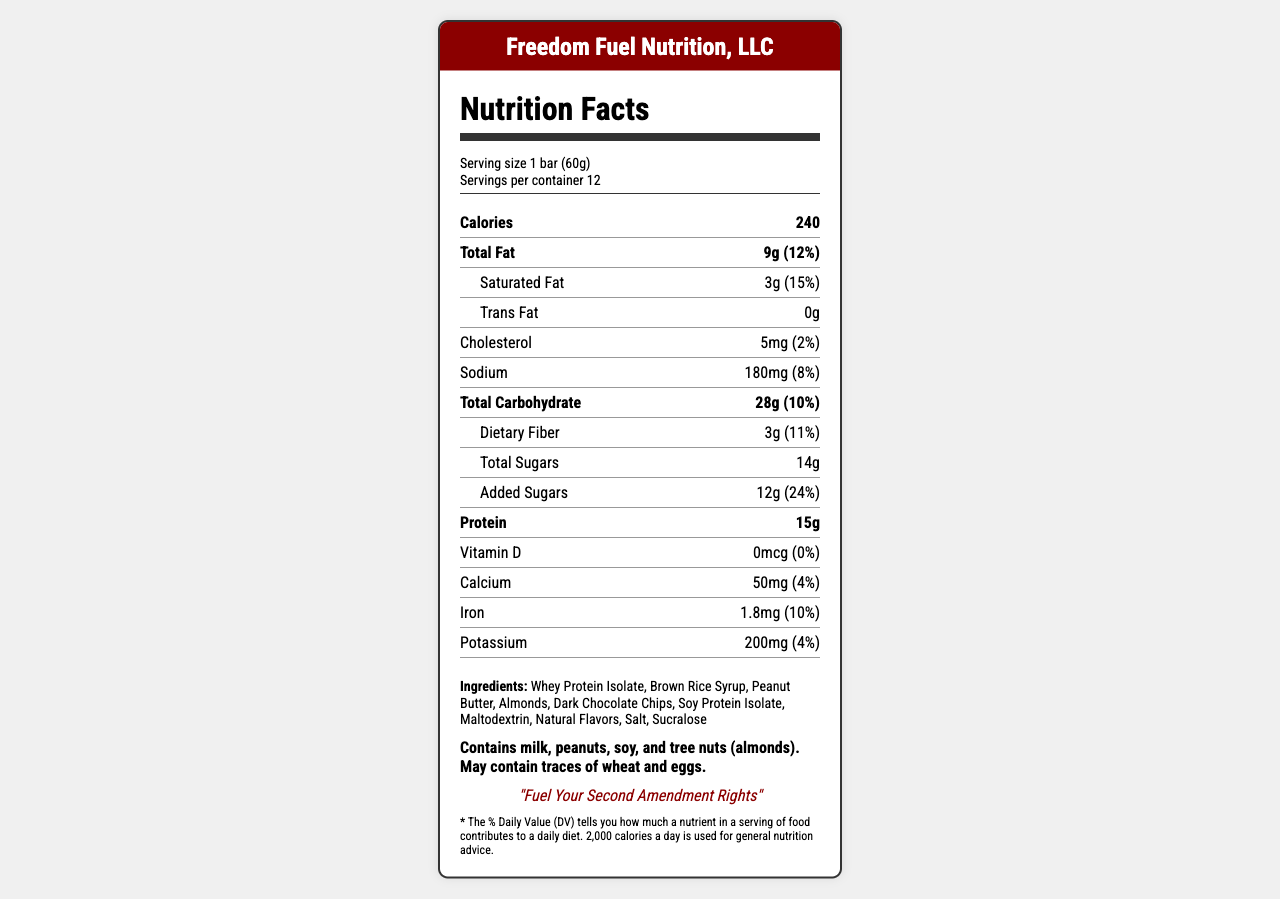what is the serving size of Patriot's Protein Punch? The serving size is directly stated as "1 bar (60g)" in the line that specifies serving information.
Answer: 1 bar (60g) how many servings are there per container? The document states "Servings per container: 12", which indicates the total number of servings.
Answer: 12 how many calories are in one serving? The document directly states "Calories: 240", which represents the calorie content per serving.
Answer: 240 what is the amount of protein in each serving? The document lists "Protein: 15g" under the nutrient information.
Answer: 15g what is the daily value percentage of added sugars? The document states "Added Sugars: 12g (24%)", providing both the amount and the daily value percentage.
Answer: 24% which ingredient is listed first? The first ingredient in the list is "Whey Protein Isolate".
Answer: Whey Protein Isolate what does the allergen information state? The allergen info section clearly states the allergens contained in the product.
Answer: Contains milk, peanuts, soy, and tree nuts (almonds). May contain traces of wheat and eggs. what is the target audience mentioned in the additional information? According to the document, the target audience is specified as "Gun enthusiasts and sportsmen".
Answer: Gun enthusiasts and sportsmen what vitamin content is absent in the Patriot's Protein Punch? Under the nutrient information, it is shown that "Vitamin D: 0mcg (0%)" is present, indicating no Vitamin D content.
Answer: Vitamin D what is the marketing claim about the bar’s size? One of the marketing claims states that the product's "Compact size fits easily in tactical vests and range bags".
Answer: Compact size fits easily in tactical vests and range bags Patriot's Protein Punch supports which type of organizations as per the marketing claims? One of the marketing claims mentions the product "Supports local gun rights organizations".
Answer: Local gun rights organizations who is the manufacturer of Patriot's Protein Punch? A. Gun Nutri-Corp B. Freedom Fuel Nutrition, LLC C. Second Amendment Supplies The document lists the manufacturer as "Freedom Fuel Nutrition, LLC".
Answer: B. Freedom Fuel Nutrition, LLC how long is the shelf life of the protein bar? A. 6 months B. 12 months C. 24 months The additional information section shows that the shelf life is "12 months".
Answer: B. 12 months does Patriot's Protein Punch contain any trans fat? The nutrient row for trans fat lists "0g", indicating that there are no trans fats in the protein bar.
Answer: No is this product intended primarily for a general audience? The target audience listed is "Gun enthusiasts and sportsmen", indicating that it is not meant for a general audience.
Answer: No summarize the main idea of the document. The document is designed to promote and inform consumers about Patriot's Protein Punch, its nutritional value, target audience, and unique selling points related to gun culture.
Answer: The document provides the nutritional information, ingredients, marketing claims, and additional facts about Patriot's Protein Punch, a protein bar marketed primarily toward gun enthusiasts and sportsmen. It is sold exclusively at gun shows and shooting ranges and emphasizes high protein content for energy during long shooting sessions. The bar contains common allergens and has a shelf life of 12 months. what is the distribution strategy of the protein bar? The document does not provide enough information to detail the specific distribution strategy beyond stating that it is "sold exclusively at gun shows and shooting ranges".
Answer: Cannot be determined 